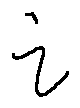Convert formula to latex. <formula><loc_0><loc_0><loc_500><loc_500>i</formula> 